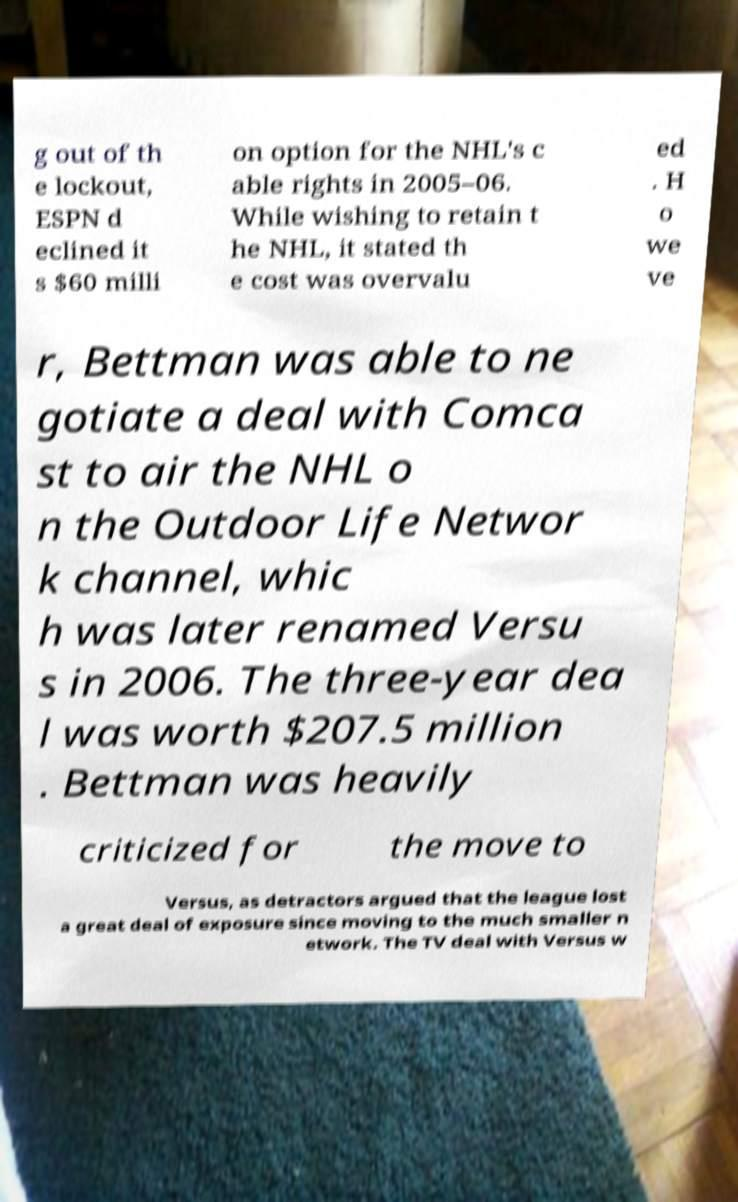For documentation purposes, I need the text within this image transcribed. Could you provide that? g out of th e lockout, ESPN d eclined it s $60 milli on option for the NHL's c able rights in 2005–06. While wishing to retain t he NHL, it stated th e cost was overvalu ed . H o we ve r, Bettman was able to ne gotiate a deal with Comca st to air the NHL o n the Outdoor Life Networ k channel, whic h was later renamed Versu s in 2006. The three-year dea l was worth $207.5 million . Bettman was heavily criticized for the move to Versus, as detractors argued that the league lost a great deal of exposure since moving to the much smaller n etwork. The TV deal with Versus w 